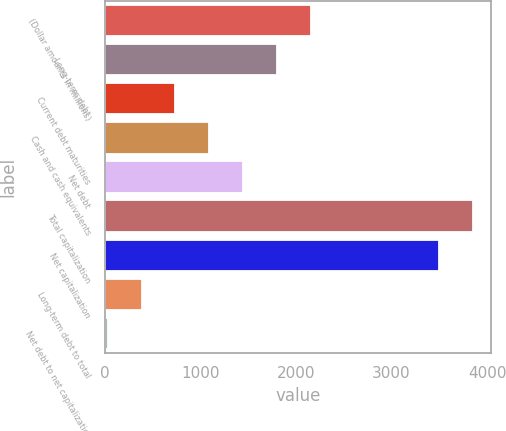Convert chart to OTSL. <chart><loc_0><loc_0><loc_500><loc_500><bar_chart><fcel>(Dollar amounts in millions)<fcel>Long-term debt<fcel>Current debt maturities<fcel>Cash and cash equivalents<fcel>Net debt<fcel>Total capitalization<fcel>Net capitalization<fcel>Long-term debt to total<fcel>Net debt to net capitalization<nl><fcel>2155.6<fcel>1801<fcel>737.2<fcel>1091.8<fcel>1446.4<fcel>3848.6<fcel>3494<fcel>382.6<fcel>28<nl></chart> 